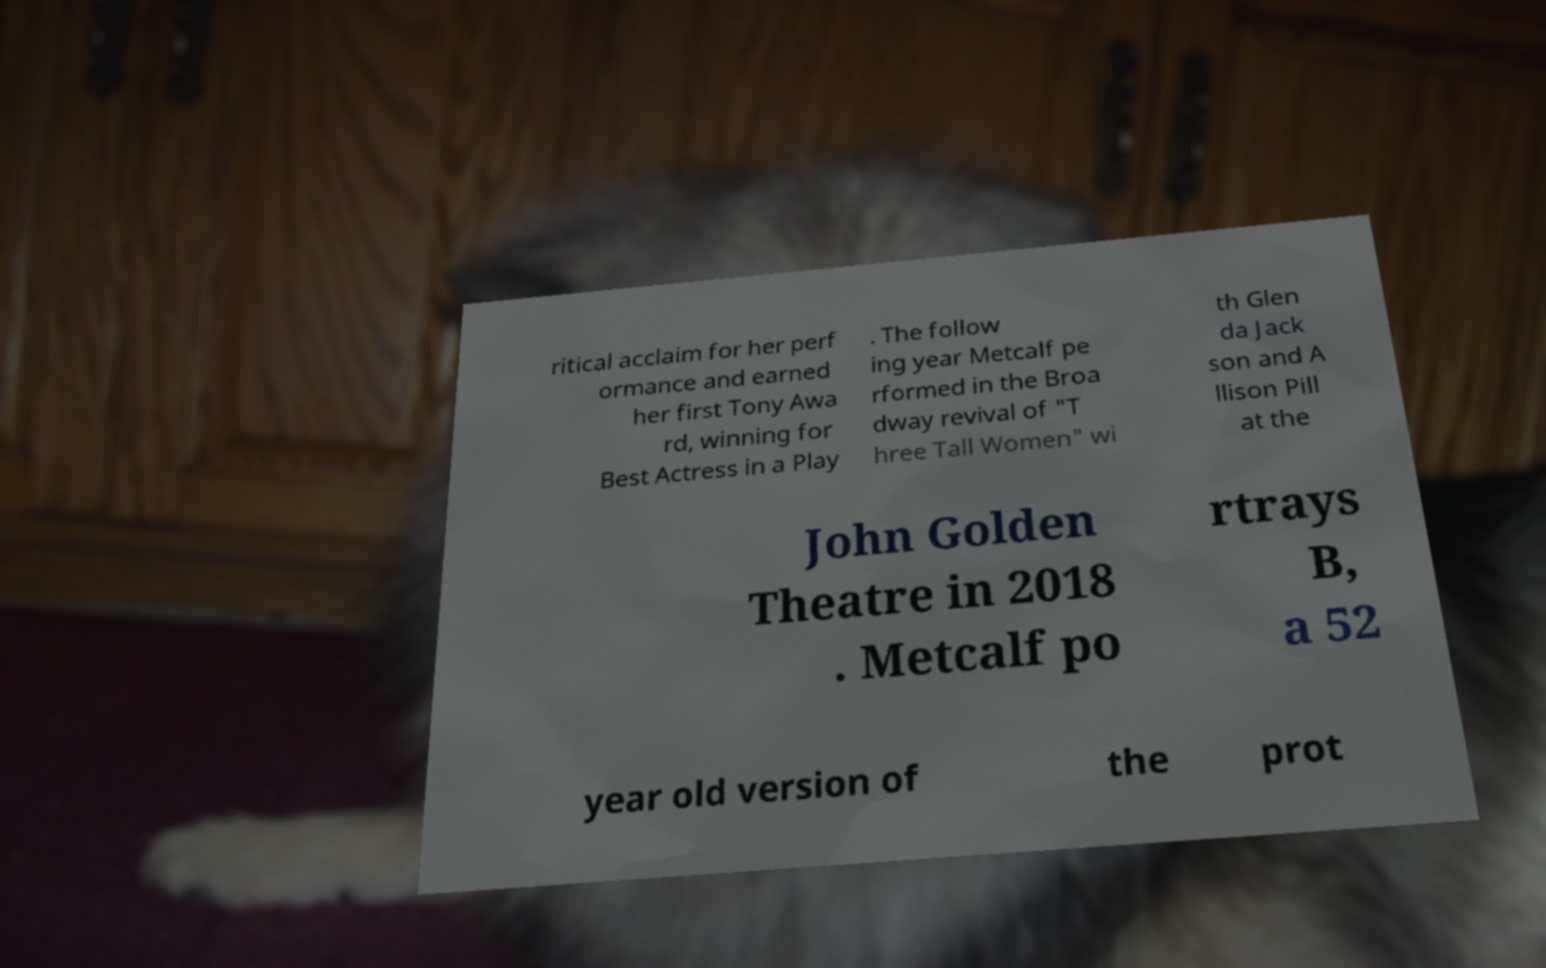What messages or text are displayed in this image? I need them in a readable, typed format. ritical acclaim for her perf ormance and earned her first Tony Awa rd, winning for Best Actress in a Play . The follow ing year Metcalf pe rformed in the Broa dway revival of "T hree Tall Women" wi th Glen da Jack son and A llison Pill at the John Golden Theatre in 2018 . Metcalf po rtrays B, a 52 year old version of the prot 